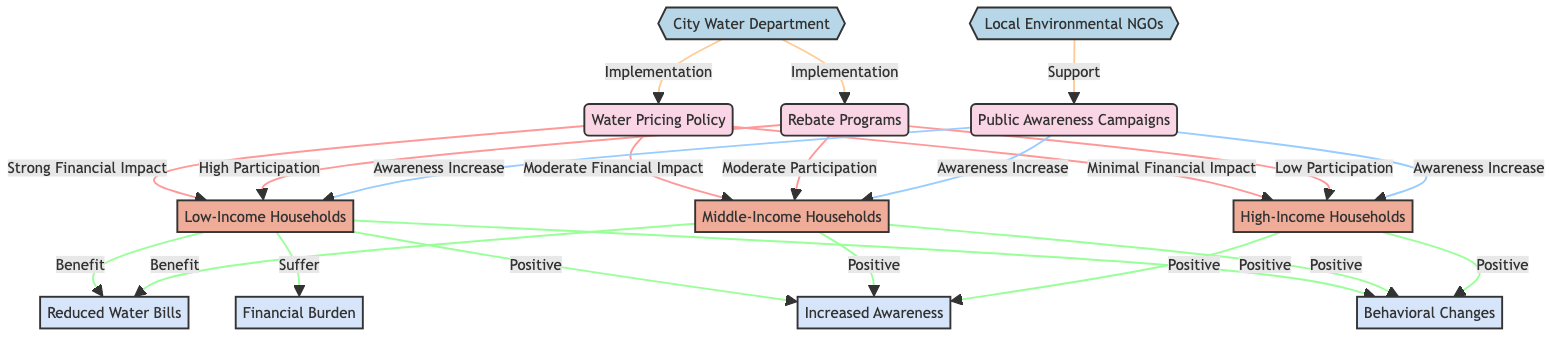What is the main impact of the Water Pricing Policy on Low-Income Households? The diagram indicates a "Strong Financial Impact" from the Water Pricing Policy to Low-Income Households. This relationship shows that this demographic group feels the financial effects of the policy most strongly.
Answer: Strong Financial Impact How many total demographic groups are represented in the diagram? The diagram features three demographic groups: Low-Income Households, Middle-Income Households, and High-Income Households. Adding these together gives a total of three groups.
Answer: 3 What type of participation is reported for Middle-Income Households in the Rebate Programs? The edge linking Rebate Programs and Middle-Income Households states "Moderate Participation," indicating that this group participates to a moderate extent in the rebate initiative.
Answer: Moderate Participation Which organization supports Public Awareness Campaigns? According to the diagram, the Local Environmental NGOs organization is connected to Public Awareness Campaigns with a label of "Support," signifying its role in backing these campaigns.
Answer: Local Environmental NGOs What is the financial impact on High-Income Households from the Water Pricing Policy? The relationship between the Water Pricing Policy and High-Income Households indicates "Minimal Financial Impact," meaning that the financial effect is low for this demographic group.
Answer: Minimal Financial Impact Which impact is described as a "Suffer" outcome for Low-Income Households? The diagram identifies Financial Burden as a "Suffer" outcome from Low-Income Households. This suggests that the group experiences negative financial consequences.
Answer: Financial Burden How many impacts are linked to High-Income Households? The diagram shows that High-Income Households are connected to three impacts: Increased Awareness, Behavioral Changes, and no negative financial burden. Adding these together results in three impacts linked to this group.
Answer: 3 What common impact do all three household groups experience from Public Awareness Campaigns? The edge from Public Awareness Campaigns to all three household groups indicates an "Awareness Increase," reflecting a shared positive benefit across the demographics.
Answer: Awareness Increase Which policy has the highest participation among Low-Income Households? The diagram shows that the Rebate Programs have "High Participation" from Low-Income Households, indicating they are most engaged with this particular policy compared to others.
Answer: High Participation 